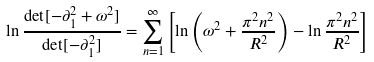Convert formula to latex. <formula><loc_0><loc_0><loc_500><loc_500>\ln \frac { \det [ - \partial _ { 1 } ^ { 2 } + \omega ^ { 2 } ] } { \det [ - \partial _ { 1 } ^ { 2 } ] } = \sum _ { n = 1 } ^ { \infty } \left [ \ln \left ( \omega ^ { 2 } + \frac { \pi ^ { 2 } n ^ { 2 } } { R ^ { 2 } } \right ) - \ln \frac { \pi ^ { 2 } n ^ { 2 } } { R ^ { 2 } } \right ]</formula> 